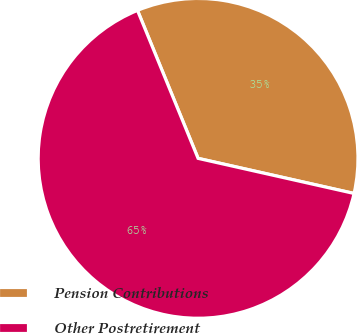Convert chart to OTSL. <chart><loc_0><loc_0><loc_500><loc_500><pie_chart><fcel>Pension Contributions<fcel>Other Postretirement<nl><fcel>34.71%<fcel>65.29%<nl></chart> 